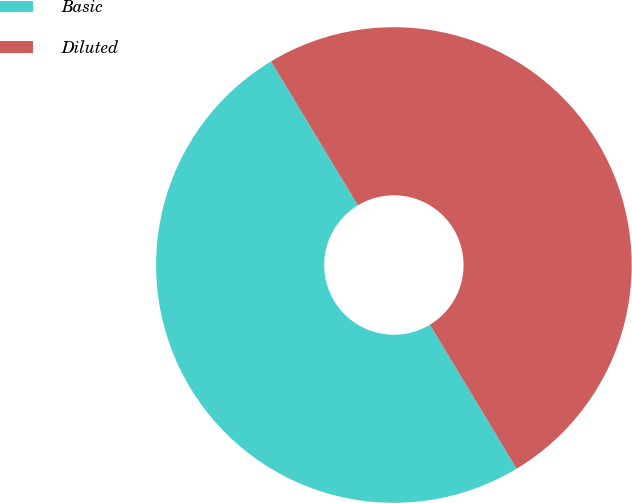<chart> <loc_0><loc_0><loc_500><loc_500><pie_chart><fcel>Basic<fcel>Diluted<nl><fcel>50.0%<fcel>50.0%<nl></chart> 